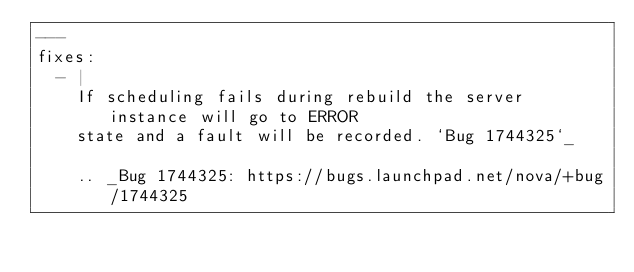Convert code to text. <code><loc_0><loc_0><loc_500><loc_500><_YAML_>---
fixes:
  - |
    If scheduling fails during rebuild the server instance will go to ERROR
    state and a fault will be recorded. `Bug 1744325`_

    .. _Bug 1744325: https://bugs.launchpad.net/nova/+bug/1744325
</code> 